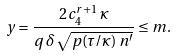<formula> <loc_0><loc_0><loc_500><loc_500>y = \frac { 2 \, c _ { 4 } ^ { r + 1 } \, \varkappa } { q \, \delta \, \sqrt { p ( \tau / \varkappa ) \, n ^ { \prime } } } \leq m .</formula> 